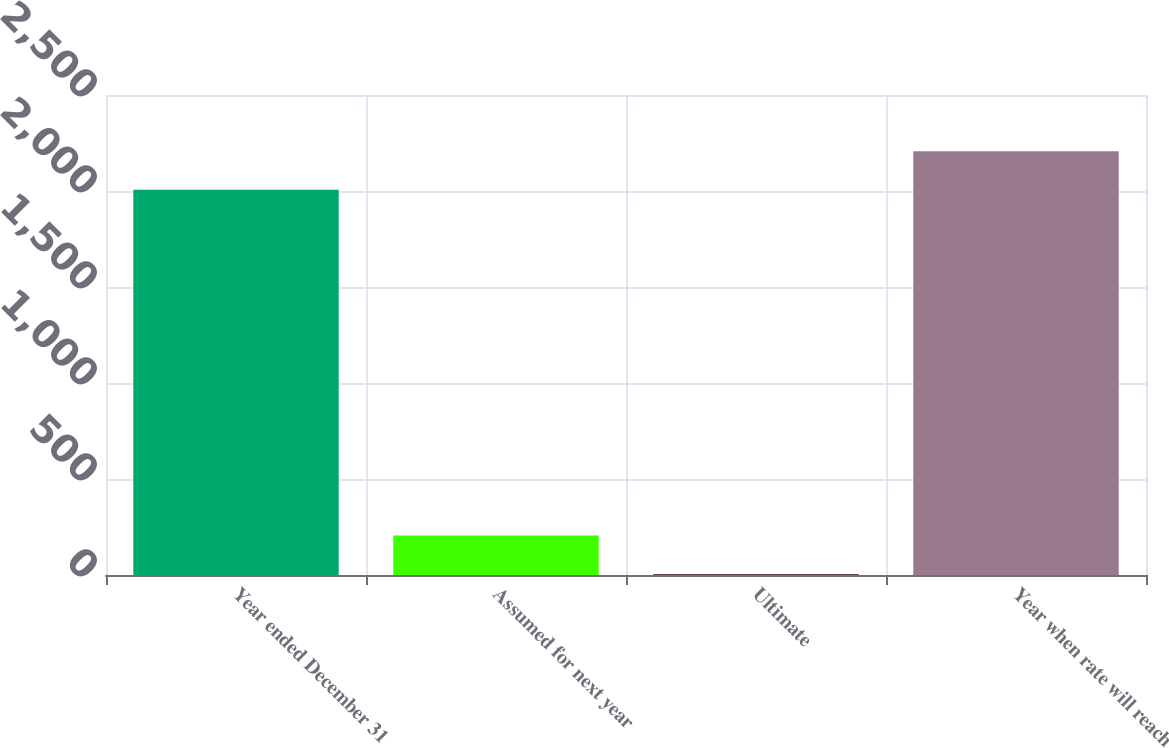<chart> <loc_0><loc_0><loc_500><loc_500><bar_chart><fcel>Year ended December 31<fcel>Assumed for next year<fcel>Ultimate<fcel>Year when rate will reach<nl><fcel>2006<fcel>205.8<fcel>5<fcel>2206.8<nl></chart> 